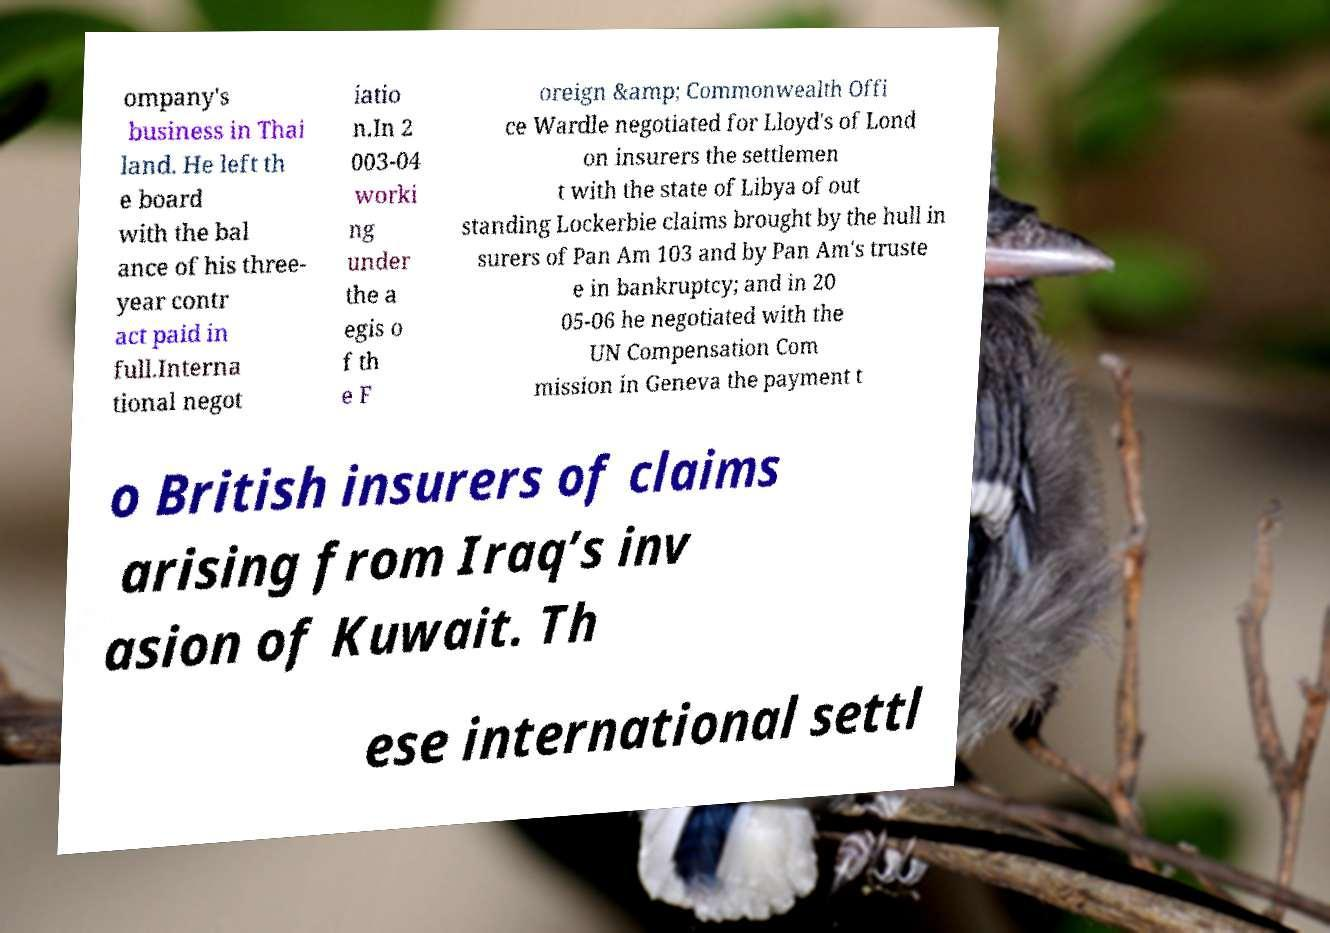Can you accurately transcribe the text from the provided image for me? ompany's business in Thai land. He left th e board with the bal ance of his three- year contr act paid in full.Interna tional negot iatio n.In 2 003-04 worki ng under the a egis o f th e F oreign &amp; Commonwealth Offi ce Wardle negotiated for Lloyd's of Lond on insurers the settlemen t with the state of Libya of out standing Lockerbie claims brought by the hull in surers of Pan Am 103 and by Pan Am's truste e in bankruptcy; and in 20 05-06 he negotiated with the UN Compensation Com mission in Geneva the payment t o British insurers of claims arising from Iraq’s inv asion of Kuwait. Th ese international settl 